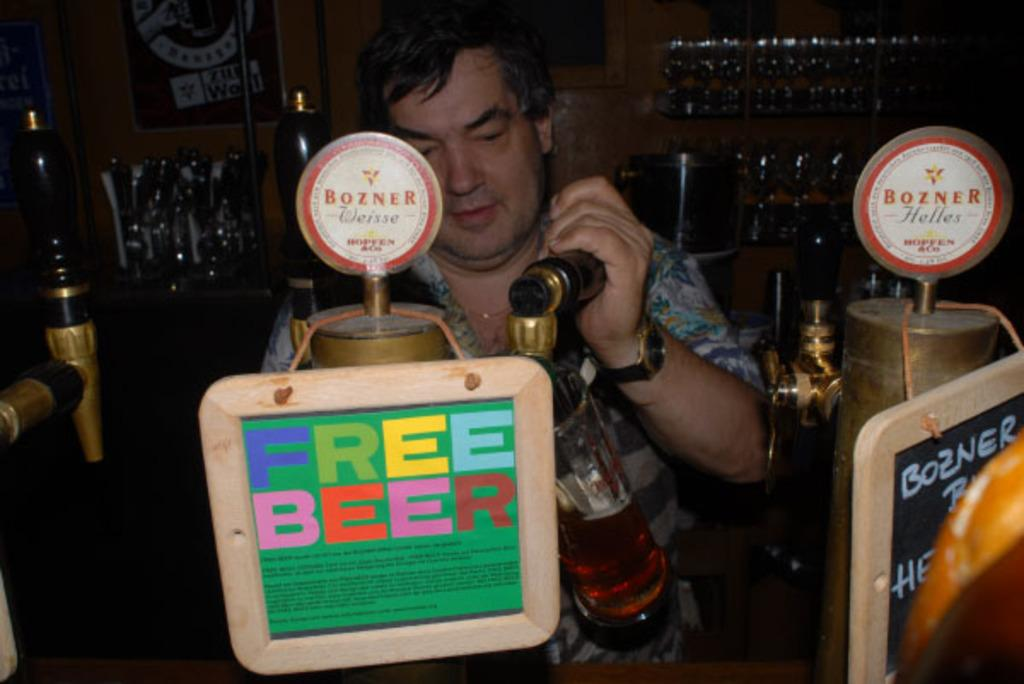<image>
Relay a brief, clear account of the picture shown. A man pouring a beer from a tap that has a sign that reads free beer on it. 